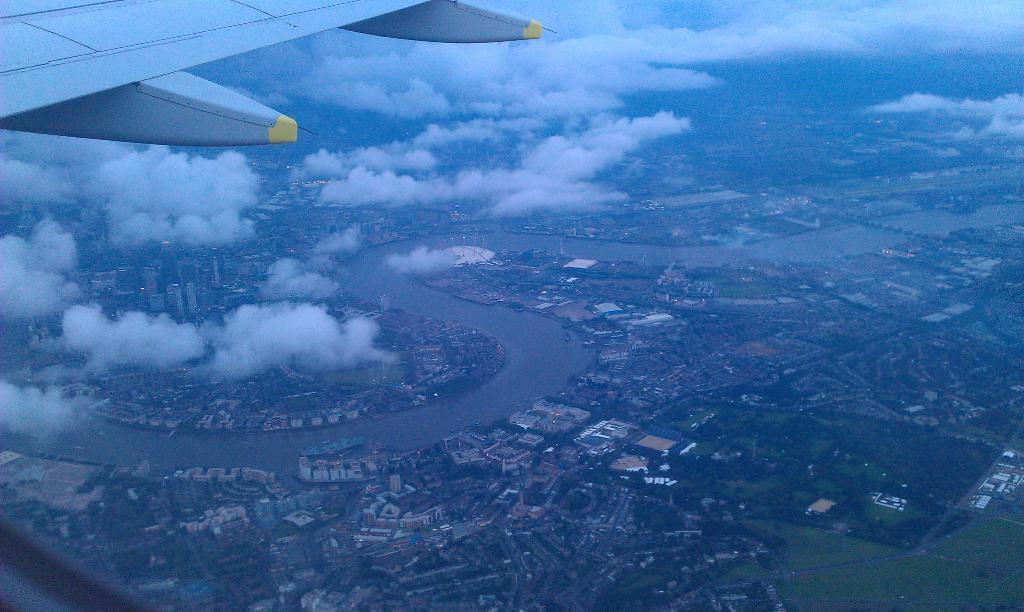What is the perspective of the image? The image is taken from a plane, providing an aerial view. What is the main subject of the image? The image shows an aerial view of a city. What can be seen in the sky in the image? There are clouds visible in the image. What type of property can be seen being built in the image? There is no property being built visible in the image; it shows an aerial view of a city. How long does it take for the clouds to move a minute in the image? The image is a still photograph and does not show the movement of clouds or any other objects. 